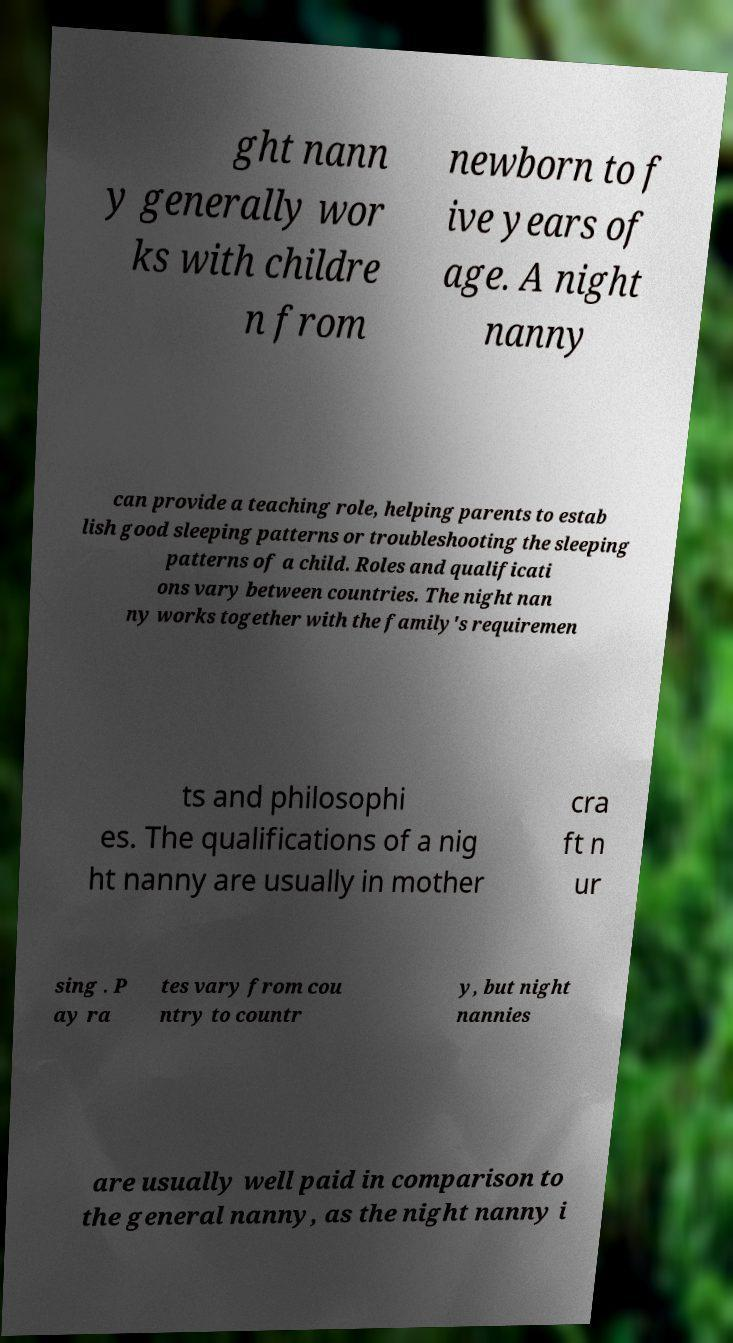Could you assist in decoding the text presented in this image and type it out clearly? ght nann y generally wor ks with childre n from newborn to f ive years of age. A night nanny can provide a teaching role, helping parents to estab lish good sleeping patterns or troubleshooting the sleeping patterns of a child. Roles and qualificati ons vary between countries. The night nan ny works together with the family's requiremen ts and philosophi es. The qualifications of a nig ht nanny are usually in mother cra ft n ur sing . P ay ra tes vary from cou ntry to countr y, but night nannies are usually well paid in comparison to the general nanny, as the night nanny i 